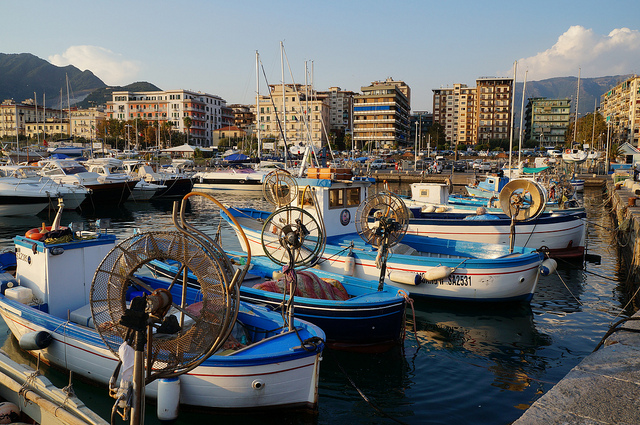Read and extract the text from this image. SA2531 